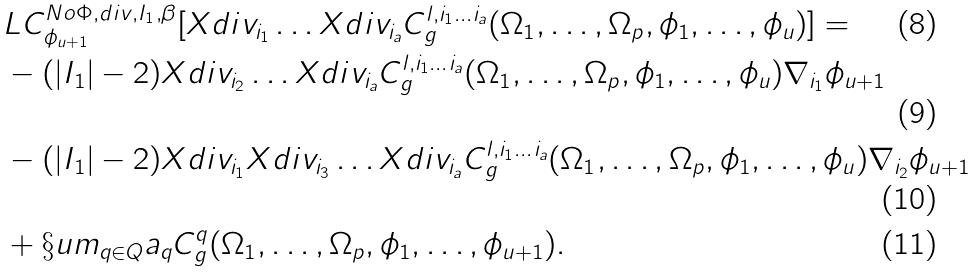<formula> <loc_0><loc_0><loc_500><loc_500>& L C ^ { N o \Phi , d i v , I _ { 1 } , \beta } _ { \phi _ { u + 1 } } [ X d i v _ { i _ { 1 } } \dots X d i v _ { i _ { a } } C ^ { l , i _ { 1 } \dots i _ { a } } _ { g } ( \Omega _ { 1 } , \dots , \Omega _ { p } , \phi _ { 1 } , \dots , \phi _ { u } ) ] = \\ & - ( | I _ { 1 } | - 2 ) X d i v _ { i _ { 2 } } \dots X d i v _ { i _ { a } } C ^ { l , i _ { 1 } \dots i _ { a } } _ { g } ( \Omega _ { 1 } , \dots , \Omega _ { p } , \phi _ { 1 } , \dots , \phi _ { u } ) \nabla _ { i _ { 1 } } \phi _ { u + 1 } \\ & - ( | I _ { 1 } | - 2 ) X d i v _ { i _ { 1 } } X d i v _ { i _ { 3 } } \dots X d i v _ { i _ { a } } C ^ { l , i _ { 1 } \dots i _ { a } } _ { g } ( \Omega _ { 1 } , \dots , \Omega _ { p } , \phi _ { 1 } , \dots , \phi _ { u } ) \nabla _ { i _ { 2 } } \phi _ { u + 1 } \\ & + \S u m _ { q \in Q } a _ { q } C ^ { q } _ { g } ( \Omega _ { 1 } , \dots , \Omega _ { p } , \phi _ { 1 } , \dots , \phi _ { u + 1 } ) .</formula> 